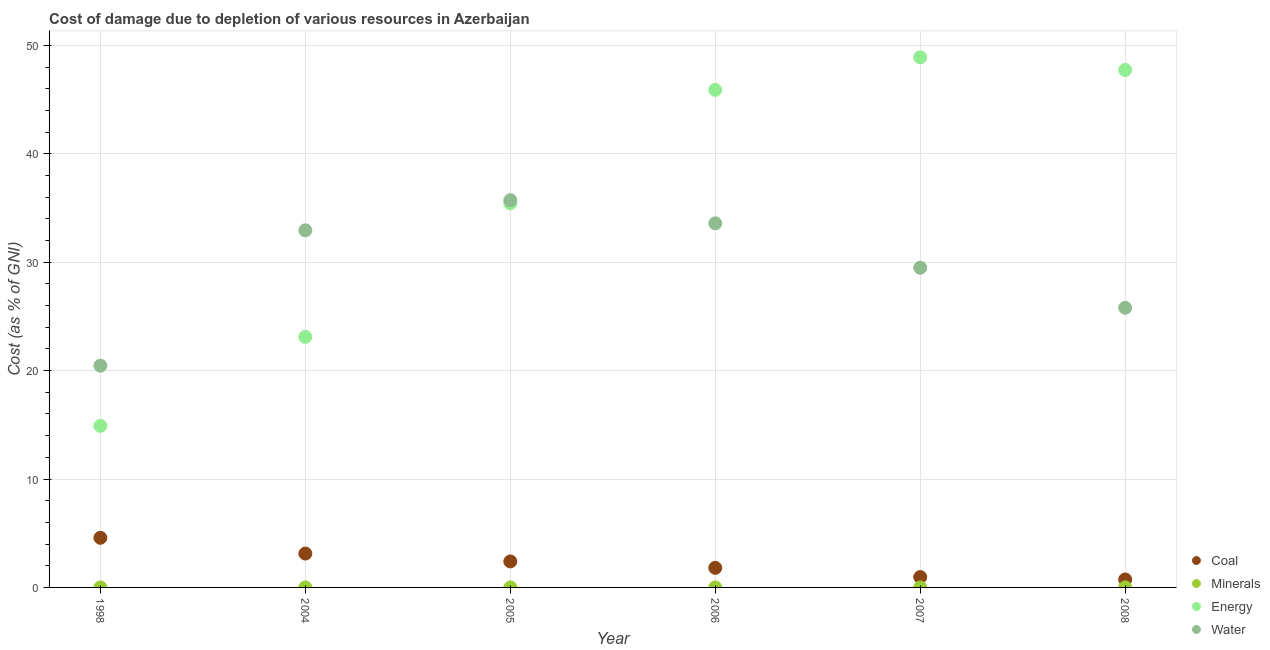What is the cost of damage due to depletion of water in 2005?
Your answer should be compact. 35.72. Across all years, what is the maximum cost of damage due to depletion of energy?
Offer a very short reply. 48.9. Across all years, what is the minimum cost of damage due to depletion of coal?
Provide a succinct answer. 0.74. In which year was the cost of damage due to depletion of minerals maximum?
Your answer should be compact. 2008. What is the total cost of damage due to depletion of minerals in the graph?
Offer a terse response. 0.01. What is the difference between the cost of damage due to depletion of water in 2005 and that in 2006?
Your answer should be very brief. 2.13. What is the difference between the cost of damage due to depletion of coal in 2007 and the cost of damage due to depletion of minerals in 2006?
Keep it short and to the point. 0.95. What is the average cost of damage due to depletion of water per year?
Provide a short and direct response. 29.66. In the year 2007, what is the difference between the cost of damage due to depletion of energy and cost of damage due to depletion of coal?
Your response must be concise. 47.94. In how many years, is the cost of damage due to depletion of energy greater than 16 %?
Provide a short and direct response. 5. What is the ratio of the cost of damage due to depletion of energy in 2004 to that in 2008?
Your answer should be very brief. 0.48. What is the difference between the highest and the second highest cost of damage due to depletion of water?
Provide a short and direct response. 2.13. What is the difference between the highest and the lowest cost of damage due to depletion of water?
Make the answer very short. 15.27. In how many years, is the cost of damage due to depletion of energy greater than the average cost of damage due to depletion of energy taken over all years?
Make the answer very short. 3. Is it the case that in every year, the sum of the cost of damage due to depletion of coal and cost of damage due to depletion of minerals is greater than the cost of damage due to depletion of energy?
Offer a terse response. No. Does the cost of damage due to depletion of energy monotonically increase over the years?
Offer a very short reply. No. Is the cost of damage due to depletion of water strictly greater than the cost of damage due to depletion of minerals over the years?
Offer a very short reply. Yes. How many dotlines are there?
Give a very brief answer. 4. What is the difference between two consecutive major ticks on the Y-axis?
Make the answer very short. 10. Are the values on the major ticks of Y-axis written in scientific E-notation?
Your answer should be compact. No. Does the graph contain any zero values?
Give a very brief answer. No. Does the graph contain grids?
Your answer should be compact. Yes. How many legend labels are there?
Offer a terse response. 4. What is the title of the graph?
Offer a terse response. Cost of damage due to depletion of various resources in Azerbaijan . What is the label or title of the X-axis?
Provide a succinct answer. Year. What is the label or title of the Y-axis?
Provide a succinct answer. Cost (as % of GNI). What is the Cost (as % of GNI) in Coal in 1998?
Your answer should be very brief. 4.58. What is the Cost (as % of GNI) of Minerals in 1998?
Your answer should be very brief. 0. What is the Cost (as % of GNI) in Energy in 1998?
Give a very brief answer. 14.9. What is the Cost (as % of GNI) in Water in 1998?
Your answer should be compact. 20.45. What is the Cost (as % of GNI) in Coal in 2004?
Give a very brief answer. 3.12. What is the Cost (as % of GNI) in Minerals in 2004?
Make the answer very short. 0. What is the Cost (as % of GNI) of Energy in 2004?
Ensure brevity in your answer.  23.11. What is the Cost (as % of GNI) of Water in 2004?
Give a very brief answer. 32.94. What is the Cost (as % of GNI) in Coal in 2005?
Make the answer very short. 2.4. What is the Cost (as % of GNI) in Minerals in 2005?
Your answer should be very brief. 0. What is the Cost (as % of GNI) in Energy in 2005?
Your response must be concise. 35.43. What is the Cost (as % of GNI) in Water in 2005?
Offer a terse response. 35.72. What is the Cost (as % of GNI) of Coal in 2006?
Provide a short and direct response. 1.81. What is the Cost (as % of GNI) of Minerals in 2006?
Offer a terse response. 0. What is the Cost (as % of GNI) of Energy in 2006?
Make the answer very short. 45.89. What is the Cost (as % of GNI) in Water in 2006?
Offer a terse response. 33.59. What is the Cost (as % of GNI) of Coal in 2007?
Your response must be concise. 0.96. What is the Cost (as % of GNI) in Minerals in 2007?
Provide a succinct answer. 0. What is the Cost (as % of GNI) in Energy in 2007?
Your answer should be compact. 48.9. What is the Cost (as % of GNI) of Water in 2007?
Provide a succinct answer. 29.49. What is the Cost (as % of GNI) of Coal in 2008?
Keep it short and to the point. 0.74. What is the Cost (as % of GNI) of Minerals in 2008?
Ensure brevity in your answer.  0. What is the Cost (as % of GNI) in Energy in 2008?
Keep it short and to the point. 47.73. What is the Cost (as % of GNI) of Water in 2008?
Make the answer very short. 25.8. Across all years, what is the maximum Cost (as % of GNI) of Coal?
Make the answer very short. 4.58. Across all years, what is the maximum Cost (as % of GNI) of Minerals?
Offer a very short reply. 0. Across all years, what is the maximum Cost (as % of GNI) in Energy?
Provide a succinct answer. 48.9. Across all years, what is the maximum Cost (as % of GNI) in Water?
Provide a succinct answer. 35.72. Across all years, what is the minimum Cost (as % of GNI) in Coal?
Your response must be concise. 0.74. Across all years, what is the minimum Cost (as % of GNI) in Minerals?
Make the answer very short. 0. Across all years, what is the minimum Cost (as % of GNI) in Energy?
Your answer should be compact. 14.9. Across all years, what is the minimum Cost (as % of GNI) in Water?
Give a very brief answer. 20.45. What is the total Cost (as % of GNI) of Coal in the graph?
Keep it short and to the point. 13.6. What is the total Cost (as % of GNI) of Minerals in the graph?
Your response must be concise. 0.01. What is the total Cost (as % of GNI) in Energy in the graph?
Ensure brevity in your answer.  215.96. What is the total Cost (as % of GNI) of Water in the graph?
Your response must be concise. 177.98. What is the difference between the Cost (as % of GNI) in Coal in 1998 and that in 2004?
Keep it short and to the point. 1.45. What is the difference between the Cost (as % of GNI) of Minerals in 1998 and that in 2004?
Keep it short and to the point. -0. What is the difference between the Cost (as % of GNI) in Energy in 1998 and that in 2004?
Your answer should be very brief. -8.21. What is the difference between the Cost (as % of GNI) of Water in 1998 and that in 2004?
Offer a terse response. -12.49. What is the difference between the Cost (as % of GNI) in Coal in 1998 and that in 2005?
Provide a short and direct response. 2.18. What is the difference between the Cost (as % of GNI) in Minerals in 1998 and that in 2005?
Give a very brief answer. -0. What is the difference between the Cost (as % of GNI) in Energy in 1998 and that in 2005?
Provide a short and direct response. -20.53. What is the difference between the Cost (as % of GNI) in Water in 1998 and that in 2005?
Your response must be concise. -15.27. What is the difference between the Cost (as % of GNI) in Coal in 1998 and that in 2006?
Offer a very short reply. 2.77. What is the difference between the Cost (as % of GNI) in Minerals in 1998 and that in 2006?
Ensure brevity in your answer.  -0. What is the difference between the Cost (as % of GNI) of Energy in 1998 and that in 2006?
Your answer should be very brief. -30.99. What is the difference between the Cost (as % of GNI) of Water in 1998 and that in 2006?
Ensure brevity in your answer.  -13.13. What is the difference between the Cost (as % of GNI) of Coal in 1998 and that in 2007?
Your response must be concise. 3.62. What is the difference between the Cost (as % of GNI) in Minerals in 1998 and that in 2007?
Provide a succinct answer. -0. What is the difference between the Cost (as % of GNI) of Energy in 1998 and that in 2007?
Ensure brevity in your answer.  -34. What is the difference between the Cost (as % of GNI) of Water in 1998 and that in 2007?
Your answer should be very brief. -9.04. What is the difference between the Cost (as % of GNI) in Coal in 1998 and that in 2008?
Keep it short and to the point. 3.84. What is the difference between the Cost (as % of GNI) of Minerals in 1998 and that in 2008?
Give a very brief answer. -0. What is the difference between the Cost (as % of GNI) of Energy in 1998 and that in 2008?
Provide a succinct answer. -32.83. What is the difference between the Cost (as % of GNI) of Water in 1998 and that in 2008?
Make the answer very short. -5.34. What is the difference between the Cost (as % of GNI) in Coal in 2004 and that in 2005?
Give a very brief answer. 0.72. What is the difference between the Cost (as % of GNI) of Minerals in 2004 and that in 2005?
Your answer should be very brief. -0. What is the difference between the Cost (as % of GNI) in Energy in 2004 and that in 2005?
Give a very brief answer. -12.32. What is the difference between the Cost (as % of GNI) in Water in 2004 and that in 2005?
Ensure brevity in your answer.  -2.78. What is the difference between the Cost (as % of GNI) of Coal in 2004 and that in 2006?
Your answer should be compact. 1.32. What is the difference between the Cost (as % of GNI) in Minerals in 2004 and that in 2006?
Provide a short and direct response. -0. What is the difference between the Cost (as % of GNI) of Energy in 2004 and that in 2006?
Offer a terse response. -22.78. What is the difference between the Cost (as % of GNI) in Water in 2004 and that in 2006?
Offer a very short reply. -0.65. What is the difference between the Cost (as % of GNI) in Coal in 2004 and that in 2007?
Your answer should be very brief. 2.17. What is the difference between the Cost (as % of GNI) in Minerals in 2004 and that in 2007?
Offer a very short reply. -0. What is the difference between the Cost (as % of GNI) in Energy in 2004 and that in 2007?
Make the answer very short. -25.79. What is the difference between the Cost (as % of GNI) of Water in 2004 and that in 2007?
Provide a short and direct response. 3.45. What is the difference between the Cost (as % of GNI) of Coal in 2004 and that in 2008?
Your answer should be very brief. 2.39. What is the difference between the Cost (as % of GNI) in Minerals in 2004 and that in 2008?
Make the answer very short. -0. What is the difference between the Cost (as % of GNI) in Energy in 2004 and that in 2008?
Make the answer very short. -24.62. What is the difference between the Cost (as % of GNI) of Water in 2004 and that in 2008?
Your answer should be very brief. 7.15. What is the difference between the Cost (as % of GNI) of Coal in 2005 and that in 2006?
Offer a very short reply. 0.59. What is the difference between the Cost (as % of GNI) of Minerals in 2005 and that in 2006?
Offer a very short reply. -0. What is the difference between the Cost (as % of GNI) in Energy in 2005 and that in 2006?
Ensure brevity in your answer.  -10.46. What is the difference between the Cost (as % of GNI) in Water in 2005 and that in 2006?
Your answer should be very brief. 2.13. What is the difference between the Cost (as % of GNI) of Coal in 2005 and that in 2007?
Offer a terse response. 1.44. What is the difference between the Cost (as % of GNI) in Minerals in 2005 and that in 2007?
Keep it short and to the point. -0. What is the difference between the Cost (as % of GNI) in Energy in 2005 and that in 2007?
Offer a terse response. -13.47. What is the difference between the Cost (as % of GNI) in Water in 2005 and that in 2007?
Keep it short and to the point. 6.23. What is the difference between the Cost (as % of GNI) in Coal in 2005 and that in 2008?
Your response must be concise. 1.66. What is the difference between the Cost (as % of GNI) in Minerals in 2005 and that in 2008?
Give a very brief answer. -0. What is the difference between the Cost (as % of GNI) of Energy in 2005 and that in 2008?
Make the answer very short. -12.3. What is the difference between the Cost (as % of GNI) in Water in 2005 and that in 2008?
Offer a terse response. 9.92. What is the difference between the Cost (as % of GNI) of Coal in 2006 and that in 2007?
Make the answer very short. 0.85. What is the difference between the Cost (as % of GNI) in Minerals in 2006 and that in 2007?
Provide a short and direct response. -0. What is the difference between the Cost (as % of GNI) of Energy in 2006 and that in 2007?
Make the answer very short. -3. What is the difference between the Cost (as % of GNI) in Water in 2006 and that in 2007?
Ensure brevity in your answer.  4.1. What is the difference between the Cost (as % of GNI) in Coal in 2006 and that in 2008?
Your answer should be compact. 1.07. What is the difference between the Cost (as % of GNI) of Minerals in 2006 and that in 2008?
Keep it short and to the point. -0. What is the difference between the Cost (as % of GNI) of Energy in 2006 and that in 2008?
Provide a succinct answer. -1.84. What is the difference between the Cost (as % of GNI) in Water in 2006 and that in 2008?
Provide a short and direct response. 7.79. What is the difference between the Cost (as % of GNI) in Coal in 2007 and that in 2008?
Your answer should be very brief. 0.22. What is the difference between the Cost (as % of GNI) of Minerals in 2007 and that in 2008?
Offer a very short reply. -0. What is the difference between the Cost (as % of GNI) in Energy in 2007 and that in 2008?
Your answer should be compact. 1.17. What is the difference between the Cost (as % of GNI) of Water in 2007 and that in 2008?
Provide a short and direct response. 3.69. What is the difference between the Cost (as % of GNI) in Coal in 1998 and the Cost (as % of GNI) in Minerals in 2004?
Your response must be concise. 4.58. What is the difference between the Cost (as % of GNI) of Coal in 1998 and the Cost (as % of GNI) of Energy in 2004?
Make the answer very short. -18.53. What is the difference between the Cost (as % of GNI) of Coal in 1998 and the Cost (as % of GNI) of Water in 2004?
Provide a short and direct response. -28.36. What is the difference between the Cost (as % of GNI) in Minerals in 1998 and the Cost (as % of GNI) in Energy in 2004?
Give a very brief answer. -23.11. What is the difference between the Cost (as % of GNI) in Minerals in 1998 and the Cost (as % of GNI) in Water in 2004?
Ensure brevity in your answer.  -32.94. What is the difference between the Cost (as % of GNI) in Energy in 1998 and the Cost (as % of GNI) in Water in 2004?
Provide a short and direct response. -18.04. What is the difference between the Cost (as % of GNI) of Coal in 1998 and the Cost (as % of GNI) of Minerals in 2005?
Make the answer very short. 4.58. What is the difference between the Cost (as % of GNI) in Coal in 1998 and the Cost (as % of GNI) in Energy in 2005?
Ensure brevity in your answer.  -30.85. What is the difference between the Cost (as % of GNI) of Coal in 1998 and the Cost (as % of GNI) of Water in 2005?
Make the answer very short. -31.14. What is the difference between the Cost (as % of GNI) of Minerals in 1998 and the Cost (as % of GNI) of Energy in 2005?
Your answer should be compact. -35.43. What is the difference between the Cost (as % of GNI) of Minerals in 1998 and the Cost (as % of GNI) of Water in 2005?
Provide a succinct answer. -35.72. What is the difference between the Cost (as % of GNI) in Energy in 1998 and the Cost (as % of GNI) in Water in 2005?
Your response must be concise. -20.82. What is the difference between the Cost (as % of GNI) in Coal in 1998 and the Cost (as % of GNI) in Minerals in 2006?
Give a very brief answer. 4.58. What is the difference between the Cost (as % of GNI) of Coal in 1998 and the Cost (as % of GNI) of Energy in 2006?
Keep it short and to the point. -41.31. What is the difference between the Cost (as % of GNI) in Coal in 1998 and the Cost (as % of GNI) in Water in 2006?
Your response must be concise. -29.01. What is the difference between the Cost (as % of GNI) in Minerals in 1998 and the Cost (as % of GNI) in Energy in 2006?
Your answer should be very brief. -45.89. What is the difference between the Cost (as % of GNI) of Minerals in 1998 and the Cost (as % of GNI) of Water in 2006?
Keep it short and to the point. -33.59. What is the difference between the Cost (as % of GNI) in Energy in 1998 and the Cost (as % of GNI) in Water in 2006?
Ensure brevity in your answer.  -18.69. What is the difference between the Cost (as % of GNI) in Coal in 1998 and the Cost (as % of GNI) in Minerals in 2007?
Keep it short and to the point. 4.58. What is the difference between the Cost (as % of GNI) of Coal in 1998 and the Cost (as % of GNI) of Energy in 2007?
Offer a terse response. -44.32. What is the difference between the Cost (as % of GNI) in Coal in 1998 and the Cost (as % of GNI) in Water in 2007?
Make the answer very short. -24.91. What is the difference between the Cost (as % of GNI) in Minerals in 1998 and the Cost (as % of GNI) in Energy in 2007?
Make the answer very short. -48.9. What is the difference between the Cost (as % of GNI) of Minerals in 1998 and the Cost (as % of GNI) of Water in 2007?
Ensure brevity in your answer.  -29.49. What is the difference between the Cost (as % of GNI) in Energy in 1998 and the Cost (as % of GNI) in Water in 2007?
Ensure brevity in your answer.  -14.59. What is the difference between the Cost (as % of GNI) in Coal in 1998 and the Cost (as % of GNI) in Minerals in 2008?
Offer a very short reply. 4.57. What is the difference between the Cost (as % of GNI) in Coal in 1998 and the Cost (as % of GNI) in Energy in 2008?
Your response must be concise. -43.15. What is the difference between the Cost (as % of GNI) in Coal in 1998 and the Cost (as % of GNI) in Water in 2008?
Offer a terse response. -21.22. What is the difference between the Cost (as % of GNI) in Minerals in 1998 and the Cost (as % of GNI) in Energy in 2008?
Provide a short and direct response. -47.73. What is the difference between the Cost (as % of GNI) of Minerals in 1998 and the Cost (as % of GNI) of Water in 2008?
Keep it short and to the point. -25.8. What is the difference between the Cost (as % of GNI) in Energy in 1998 and the Cost (as % of GNI) in Water in 2008?
Offer a very short reply. -10.9. What is the difference between the Cost (as % of GNI) of Coal in 2004 and the Cost (as % of GNI) of Minerals in 2005?
Make the answer very short. 3.12. What is the difference between the Cost (as % of GNI) of Coal in 2004 and the Cost (as % of GNI) of Energy in 2005?
Make the answer very short. -32.31. What is the difference between the Cost (as % of GNI) of Coal in 2004 and the Cost (as % of GNI) of Water in 2005?
Make the answer very short. -32.6. What is the difference between the Cost (as % of GNI) of Minerals in 2004 and the Cost (as % of GNI) of Energy in 2005?
Your answer should be compact. -35.43. What is the difference between the Cost (as % of GNI) in Minerals in 2004 and the Cost (as % of GNI) in Water in 2005?
Your response must be concise. -35.72. What is the difference between the Cost (as % of GNI) of Energy in 2004 and the Cost (as % of GNI) of Water in 2005?
Your answer should be compact. -12.61. What is the difference between the Cost (as % of GNI) of Coal in 2004 and the Cost (as % of GNI) of Minerals in 2006?
Offer a terse response. 3.12. What is the difference between the Cost (as % of GNI) of Coal in 2004 and the Cost (as % of GNI) of Energy in 2006?
Give a very brief answer. -42.77. What is the difference between the Cost (as % of GNI) of Coal in 2004 and the Cost (as % of GNI) of Water in 2006?
Ensure brevity in your answer.  -30.46. What is the difference between the Cost (as % of GNI) in Minerals in 2004 and the Cost (as % of GNI) in Energy in 2006?
Offer a very short reply. -45.89. What is the difference between the Cost (as % of GNI) of Minerals in 2004 and the Cost (as % of GNI) of Water in 2006?
Provide a succinct answer. -33.58. What is the difference between the Cost (as % of GNI) in Energy in 2004 and the Cost (as % of GNI) in Water in 2006?
Your response must be concise. -10.48. What is the difference between the Cost (as % of GNI) in Coal in 2004 and the Cost (as % of GNI) in Minerals in 2007?
Ensure brevity in your answer.  3.12. What is the difference between the Cost (as % of GNI) of Coal in 2004 and the Cost (as % of GNI) of Energy in 2007?
Give a very brief answer. -45.77. What is the difference between the Cost (as % of GNI) in Coal in 2004 and the Cost (as % of GNI) in Water in 2007?
Offer a very short reply. -26.37. What is the difference between the Cost (as % of GNI) in Minerals in 2004 and the Cost (as % of GNI) in Energy in 2007?
Your answer should be compact. -48.9. What is the difference between the Cost (as % of GNI) of Minerals in 2004 and the Cost (as % of GNI) of Water in 2007?
Offer a very short reply. -29.49. What is the difference between the Cost (as % of GNI) in Energy in 2004 and the Cost (as % of GNI) in Water in 2007?
Give a very brief answer. -6.38. What is the difference between the Cost (as % of GNI) of Coal in 2004 and the Cost (as % of GNI) of Minerals in 2008?
Your answer should be very brief. 3.12. What is the difference between the Cost (as % of GNI) in Coal in 2004 and the Cost (as % of GNI) in Energy in 2008?
Offer a very short reply. -44.61. What is the difference between the Cost (as % of GNI) of Coal in 2004 and the Cost (as % of GNI) of Water in 2008?
Your answer should be compact. -22.67. What is the difference between the Cost (as % of GNI) in Minerals in 2004 and the Cost (as % of GNI) in Energy in 2008?
Give a very brief answer. -47.73. What is the difference between the Cost (as % of GNI) in Minerals in 2004 and the Cost (as % of GNI) in Water in 2008?
Your response must be concise. -25.79. What is the difference between the Cost (as % of GNI) in Energy in 2004 and the Cost (as % of GNI) in Water in 2008?
Offer a terse response. -2.69. What is the difference between the Cost (as % of GNI) in Coal in 2005 and the Cost (as % of GNI) in Minerals in 2006?
Offer a terse response. 2.4. What is the difference between the Cost (as % of GNI) in Coal in 2005 and the Cost (as % of GNI) in Energy in 2006?
Make the answer very short. -43.49. What is the difference between the Cost (as % of GNI) of Coal in 2005 and the Cost (as % of GNI) of Water in 2006?
Keep it short and to the point. -31.19. What is the difference between the Cost (as % of GNI) of Minerals in 2005 and the Cost (as % of GNI) of Energy in 2006?
Provide a succinct answer. -45.89. What is the difference between the Cost (as % of GNI) of Minerals in 2005 and the Cost (as % of GNI) of Water in 2006?
Provide a short and direct response. -33.58. What is the difference between the Cost (as % of GNI) in Energy in 2005 and the Cost (as % of GNI) in Water in 2006?
Ensure brevity in your answer.  1.84. What is the difference between the Cost (as % of GNI) of Coal in 2005 and the Cost (as % of GNI) of Minerals in 2007?
Provide a succinct answer. 2.4. What is the difference between the Cost (as % of GNI) of Coal in 2005 and the Cost (as % of GNI) of Energy in 2007?
Offer a very short reply. -46.5. What is the difference between the Cost (as % of GNI) in Coal in 2005 and the Cost (as % of GNI) in Water in 2007?
Your answer should be compact. -27.09. What is the difference between the Cost (as % of GNI) in Minerals in 2005 and the Cost (as % of GNI) in Energy in 2007?
Provide a short and direct response. -48.9. What is the difference between the Cost (as % of GNI) in Minerals in 2005 and the Cost (as % of GNI) in Water in 2007?
Provide a short and direct response. -29.49. What is the difference between the Cost (as % of GNI) in Energy in 2005 and the Cost (as % of GNI) in Water in 2007?
Offer a very short reply. 5.94. What is the difference between the Cost (as % of GNI) in Coal in 2005 and the Cost (as % of GNI) in Minerals in 2008?
Your response must be concise. 2.4. What is the difference between the Cost (as % of GNI) of Coal in 2005 and the Cost (as % of GNI) of Energy in 2008?
Make the answer very short. -45.33. What is the difference between the Cost (as % of GNI) in Coal in 2005 and the Cost (as % of GNI) in Water in 2008?
Your answer should be compact. -23.4. What is the difference between the Cost (as % of GNI) in Minerals in 2005 and the Cost (as % of GNI) in Energy in 2008?
Ensure brevity in your answer.  -47.73. What is the difference between the Cost (as % of GNI) of Minerals in 2005 and the Cost (as % of GNI) of Water in 2008?
Your answer should be compact. -25.79. What is the difference between the Cost (as % of GNI) of Energy in 2005 and the Cost (as % of GNI) of Water in 2008?
Your answer should be compact. 9.63. What is the difference between the Cost (as % of GNI) in Coal in 2006 and the Cost (as % of GNI) in Minerals in 2007?
Offer a very short reply. 1.8. What is the difference between the Cost (as % of GNI) in Coal in 2006 and the Cost (as % of GNI) in Energy in 2007?
Your response must be concise. -47.09. What is the difference between the Cost (as % of GNI) in Coal in 2006 and the Cost (as % of GNI) in Water in 2007?
Keep it short and to the point. -27.68. What is the difference between the Cost (as % of GNI) in Minerals in 2006 and the Cost (as % of GNI) in Energy in 2007?
Offer a terse response. -48.9. What is the difference between the Cost (as % of GNI) in Minerals in 2006 and the Cost (as % of GNI) in Water in 2007?
Make the answer very short. -29.49. What is the difference between the Cost (as % of GNI) in Energy in 2006 and the Cost (as % of GNI) in Water in 2007?
Provide a succinct answer. 16.4. What is the difference between the Cost (as % of GNI) in Coal in 2006 and the Cost (as % of GNI) in Minerals in 2008?
Provide a short and direct response. 1.8. What is the difference between the Cost (as % of GNI) in Coal in 2006 and the Cost (as % of GNI) in Energy in 2008?
Keep it short and to the point. -45.92. What is the difference between the Cost (as % of GNI) in Coal in 2006 and the Cost (as % of GNI) in Water in 2008?
Your response must be concise. -23.99. What is the difference between the Cost (as % of GNI) of Minerals in 2006 and the Cost (as % of GNI) of Energy in 2008?
Ensure brevity in your answer.  -47.73. What is the difference between the Cost (as % of GNI) of Minerals in 2006 and the Cost (as % of GNI) of Water in 2008?
Offer a terse response. -25.79. What is the difference between the Cost (as % of GNI) of Energy in 2006 and the Cost (as % of GNI) of Water in 2008?
Offer a very short reply. 20.1. What is the difference between the Cost (as % of GNI) of Coal in 2007 and the Cost (as % of GNI) of Minerals in 2008?
Your answer should be very brief. 0.95. What is the difference between the Cost (as % of GNI) of Coal in 2007 and the Cost (as % of GNI) of Energy in 2008?
Provide a short and direct response. -46.78. What is the difference between the Cost (as % of GNI) in Coal in 2007 and the Cost (as % of GNI) in Water in 2008?
Ensure brevity in your answer.  -24.84. What is the difference between the Cost (as % of GNI) of Minerals in 2007 and the Cost (as % of GNI) of Energy in 2008?
Keep it short and to the point. -47.73. What is the difference between the Cost (as % of GNI) in Minerals in 2007 and the Cost (as % of GNI) in Water in 2008?
Provide a succinct answer. -25.79. What is the difference between the Cost (as % of GNI) in Energy in 2007 and the Cost (as % of GNI) in Water in 2008?
Make the answer very short. 23.1. What is the average Cost (as % of GNI) in Coal per year?
Offer a terse response. 2.27. What is the average Cost (as % of GNI) in Minerals per year?
Provide a succinct answer. 0. What is the average Cost (as % of GNI) in Energy per year?
Offer a terse response. 35.99. What is the average Cost (as % of GNI) of Water per year?
Ensure brevity in your answer.  29.66. In the year 1998, what is the difference between the Cost (as % of GNI) of Coal and Cost (as % of GNI) of Minerals?
Keep it short and to the point. 4.58. In the year 1998, what is the difference between the Cost (as % of GNI) in Coal and Cost (as % of GNI) in Energy?
Make the answer very short. -10.32. In the year 1998, what is the difference between the Cost (as % of GNI) in Coal and Cost (as % of GNI) in Water?
Make the answer very short. -15.87. In the year 1998, what is the difference between the Cost (as % of GNI) of Minerals and Cost (as % of GNI) of Energy?
Keep it short and to the point. -14.9. In the year 1998, what is the difference between the Cost (as % of GNI) in Minerals and Cost (as % of GNI) in Water?
Your answer should be compact. -20.45. In the year 1998, what is the difference between the Cost (as % of GNI) in Energy and Cost (as % of GNI) in Water?
Provide a short and direct response. -5.55. In the year 2004, what is the difference between the Cost (as % of GNI) in Coal and Cost (as % of GNI) in Minerals?
Offer a terse response. 3.12. In the year 2004, what is the difference between the Cost (as % of GNI) in Coal and Cost (as % of GNI) in Energy?
Give a very brief answer. -19.99. In the year 2004, what is the difference between the Cost (as % of GNI) in Coal and Cost (as % of GNI) in Water?
Make the answer very short. -29.82. In the year 2004, what is the difference between the Cost (as % of GNI) of Minerals and Cost (as % of GNI) of Energy?
Provide a short and direct response. -23.11. In the year 2004, what is the difference between the Cost (as % of GNI) of Minerals and Cost (as % of GNI) of Water?
Your answer should be compact. -32.94. In the year 2004, what is the difference between the Cost (as % of GNI) in Energy and Cost (as % of GNI) in Water?
Your answer should be compact. -9.83. In the year 2005, what is the difference between the Cost (as % of GNI) of Coal and Cost (as % of GNI) of Minerals?
Your answer should be very brief. 2.4. In the year 2005, what is the difference between the Cost (as % of GNI) of Coal and Cost (as % of GNI) of Energy?
Give a very brief answer. -33.03. In the year 2005, what is the difference between the Cost (as % of GNI) of Coal and Cost (as % of GNI) of Water?
Offer a terse response. -33.32. In the year 2005, what is the difference between the Cost (as % of GNI) in Minerals and Cost (as % of GNI) in Energy?
Provide a short and direct response. -35.43. In the year 2005, what is the difference between the Cost (as % of GNI) of Minerals and Cost (as % of GNI) of Water?
Provide a succinct answer. -35.72. In the year 2005, what is the difference between the Cost (as % of GNI) of Energy and Cost (as % of GNI) of Water?
Offer a terse response. -0.29. In the year 2006, what is the difference between the Cost (as % of GNI) in Coal and Cost (as % of GNI) in Minerals?
Your response must be concise. 1.81. In the year 2006, what is the difference between the Cost (as % of GNI) of Coal and Cost (as % of GNI) of Energy?
Your response must be concise. -44.09. In the year 2006, what is the difference between the Cost (as % of GNI) in Coal and Cost (as % of GNI) in Water?
Keep it short and to the point. -31.78. In the year 2006, what is the difference between the Cost (as % of GNI) of Minerals and Cost (as % of GNI) of Energy?
Offer a terse response. -45.89. In the year 2006, what is the difference between the Cost (as % of GNI) of Minerals and Cost (as % of GNI) of Water?
Your answer should be compact. -33.58. In the year 2006, what is the difference between the Cost (as % of GNI) of Energy and Cost (as % of GNI) of Water?
Provide a short and direct response. 12.31. In the year 2007, what is the difference between the Cost (as % of GNI) of Coal and Cost (as % of GNI) of Minerals?
Your answer should be very brief. 0.95. In the year 2007, what is the difference between the Cost (as % of GNI) in Coal and Cost (as % of GNI) in Energy?
Your answer should be very brief. -47.94. In the year 2007, what is the difference between the Cost (as % of GNI) in Coal and Cost (as % of GNI) in Water?
Provide a short and direct response. -28.53. In the year 2007, what is the difference between the Cost (as % of GNI) of Minerals and Cost (as % of GNI) of Energy?
Offer a very short reply. -48.89. In the year 2007, what is the difference between the Cost (as % of GNI) in Minerals and Cost (as % of GNI) in Water?
Provide a succinct answer. -29.49. In the year 2007, what is the difference between the Cost (as % of GNI) in Energy and Cost (as % of GNI) in Water?
Offer a very short reply. 19.41. In the year 2008, what is the difference between the Cost (as % of GNI) of Coal and Cost (as % of GNI) of Minerals?
Your response must be concise. 0.73. In the year 2008, what is the difference between the Cost (as % of GNI) of Coal and Cost (as % of GNI) of Energy?
Offer a terse response. -47. In the year 2008, what is the difference between the Cost (as % of GNI) in Coal and Cost (as % of GNI) in Water?
Give a very brief answer. -25.06. In the year 2008, what is the difference between the Cost (as % of GNI) in Minerals and Cost (as % of GNI) in Energy?
Provide a succinct answer. -47.73. In the year 2008, what is the difference between the Cost (as % of GNI) of Minerals and Cost (as % of GNI) of Water?
Your answer should be very brief. -25.79. In the year 2008, what is the difference between the Cost (as % of GNI) of Energy and Cost (as % of GNI) of Water?
Keep it short and to the point. 21.94. What is the ratio of the Cost (as % of GNI) in Coal in 1998 to that in 2004?
Offer a very short reply. 1.47. What is the ratio of the Cost (as % of GNI) in Minerals in 1998 to that in 2004?
Provide a short and direct response. 0.2. What is the ratio of the Cost (as % of GNI) of Energy in 1998 to that in 2004?
Keep it short and to the point. 0.64. What is the ratio of the Cost (as % of GNI) of Water in 1998 to that in 2004?
Offer a terse response. 0.62. What is the ratio of the Cost (as % of GNI) in Coal in 1998 to that in 2005?
Offer a very short reply. 1.91. What is the ratio of the Cost (as % of GNI) of Minerals in 1998 to that in 2005?
Your response must be concise. 0.18. What is the ratio of the Cost (as % of GNI) in Energy in 1998 to that in 2005?
Your response must be concise. 0.42. What is the ratio of the Cost (as % of GNI) of Water in 1998 to that in 2005?
Provide a short and direct response. 0.57. What is the ratio of the Cost (as % of GNI) of Coal in 1998 to that in 2006?
Offer a very short reply. 2.53. What is the ratio of the Cost (as % of GNI) of Minerals in 1998 to that in 2006?
Your response must be concise. 0.17. What is the ratio of the Cost (as % of GNI) in Energy in 1998 to that in 2006?
Your response must be concise. 0.32. What is the ratio of the Cost (as % of GNI) of Water in 1998 to that in 2006?
Offer a terse response. 0.61. What is the ratio of the Cost (as % of GNI) of Coal in 1998 to that in 2007?
Provide a succinct answer. 4.79. What is the ratio of the Cost (as % of GNI) in Minerals in 1998 to that in 2007?
Keep it short and to the point. 0.07. What is the ratio of the Cost (as % of GNI) of Energy in 1998 to that in 2007?
Your answer should be compact. 0.3. What is the ratio of the Cost (as % of GNI) in Water in 1998 to that in 2007?
Provide a short and direct response. 0.69. What is the ratio of the Cost (as % of GNI) in Coal in 1998 to that in 2008?
Ensure brevity in your answer.  6.23. What is the ratio of the Cost (as % of GNI) in Minerals in 1998 to that in 2008?
Offer a terse response. 0.05. What is the ratio of the Cost (as % of GNI) of Energy in 1998 to that in 2008?
Your response must be concise. 0.31. What is the ratio of the Cost (as % of GNI) of Water in 1998 to that in 2008?
Keep it short and to the point. 0.79. What is the ratio of the Cost (as % of GNI) in Coal in 2004 to that in 2005?
Offer a very short reply. 1.3. What is the ratio of the Cost (as % of GNI) in Minerals in 2004 to that in 2005?
Your response must be concise. 0.94. What is the ratio of the Cost (as % of GNI) in Energy in 2004 to that in 2005?
Your answer should be compact. 0.65. What is the ratio of the Cost (as % of GNI) in Water in 2004 to that in 2005?
Provide a succinct answer. 0.92. What is the ratio of the Cost (as % of GNI) in Coal in 2004 to that in 2006?
Your answer should be very brief. 1.73. What is the ratio of the Cost (as % of GNI) in Minerals in 2004 to that in 2006?
Your answer should be very brief. 0.87. What is the ratio of the Cost (as % of GNI) of Energy in 2004 to that in 2006?
Your answer should be very brief. 0.5. What is the ratio of the Cost (as % of GNI) of Water in 2004 to that in 2006?
Your response must be concise. 0.98. What is the ratio of the Cost (as % of GNI) in Coal in 2004 to that in 2007?
Ensure brevity in your answer.  3.27. What is the ratio of the Cost (as % of GNI) in Minerals in 2004 to that in 2007?
Provide a succinct answer. 0.36. What is the ratio of the Cost (as % of GNI) of Energy in 2004 to that in 2007?
Provide a short and direct response. 0.47. What is the ratio of the Cost (as % of GNI) in Water in 2004 to that in 2007?
Give a very brief answer. 1.12. What is the ratio of the Cost (as % of GNI) in Coal in 2004 to that in 2008?
Offer a very short reply. 4.25. What is the ratio of the Cost (as % of GNI) of Minerals in 2004 to that in 2008?
Offer a very short reply. 0.26. What is the ratio of the Cost (as % of GNI) of Energy in 2004 to that in 2008?
Make the answer very short. 0.48. What is the ratio of the Cost (as % of GNI) in Water in 2004 to that in 2008?
Your response must be concise. 1.28. What is the ratio of the Cost (as % of GNI) of Coal in 2005 to that in 2006?
Provide a short and direct response. 1.33. What is the ratio of the Cost (as % of GNI) in Minerals in 2005 to that in 2006?
Your answer should be very brief. 0.92. What is the ratio of the Cost (as % of GNI) in Energy in 2005 to that in 2006?
Make the answer very short. 0.77. What is the ratio of the Cost (as % of GNI) in Water in 2005 to that in 2006?
Make the answer very short. 1.06. What is the ratio of the Cost (as % of GNI) of Coal in 2005 to that in 2007?
Provide a succinct answer. 2.51. What is the ratio of the Cost (as % of GNI) in Minerals in 2005 to that in 2007?
Your answer should be compact. 0.39. What is the ratio of the Cost (as % of GNI) of Energy in 2005 to that in 2007?
Give a very brief answer. 0.72. What is the ratio of the Cost (as % of GNI) of Water in 2005 to that in 2007?
Provide a short and direct response. 1.21. What is the ratio of the Cost (as % of GNI) of Coal in 2005 to that in 2008?
Keep it short and to the point. 3.26. What is the ratio of the Cost (as % of GNI) of Minerals in 2005 to that in 2008?
Provide a succinct answer. 0.28. What is the ratio of the Cost (as % of GNI) in Energy in 2005 to that in 2008?
Ensure brevity in your answer.  0.74. What is the ratio of the Cost (as % of GNI) of Water in 2005 to that in 2008?
Provide a succinct answer. 1.38. What is the ratio of the Cost (as % of GNI) of Coal in 2006 to that in 2007?
Your answer should be compact. 1.89. What is the ratio of the Cost (as % of GNI) in Minerals in 2006 to that in 2007?
Provide a short and direct response. 0.42. What is the ratio of the Cost (as % of GNI) in Energy in 2006 to that in 2007?
Make the answer very short. 0.94. What is the ratio of the Cost (as % of GNI) of Water in 2006 to that in 2007?
Ensure brevity in your answer.  1.14. What is the ratio of the Cost (as % of GNI) of Coal in 2006 to that in 2008?
Ensure brevity in your answer.  2.46. What is the ratio of the Cost (as % of GNI) of Minerals in 2006 to that in 2008?
Make the answer very short. 0.3. What is the ratio of the Cost (as % of GNI) of Energy in 2006 to that in 2008?
Your answer should be compact. 0.96. What is the ratio of the Cost (as % of GNI) of Water in 2006 to that in 2008?
Keep it short and to the point. 1.3. What is the ratio of the Cost (as % of GNI) in Coal in 2007 to that in 2008?
Your answer should be very brief. 1.3. What is the ratio of the Cost (as % of GNI) in Minerals in 2007 to that in 2008?
Your answer should be compact. 0.73. What is the ratio of the Cost (as % of GNI) of Energy in 2007 to that in 2008?
Your response must be concise. 1.02. What is the ratio of the Cost (as % of GNI) of Water in 2007 to that in 2008?
Offer a terse response. 1.14. What is the difference between the highest and the second highest Cost (as % of GNI) of Coal?
Give a very brief answer. 1.45. What is the difference between the highest and the second highest Cost (as % of GNI) of Minerals?
Ensure brevity in your answer.  0. What is the difference between the highest and the second highest Cost (as % of GNI) in Energy?
Keep it short and to the point. 1.17. What is the difference between the highest and the second highest Cost (as % of GNI) of Water?
Keep it short and to the point. 2.13. What is the difference between the highest and the lowest Cost (as % of GNI) of Coal?
Your answer should be compact. 3.84. What is the difference between the highest and the lowest Cost (as % of GNI) of Minerals?
Keep it short and to the point. 0. What is the difference between the highest and the lowest Cost (as % of GNI) of Energy?
Your response must be concise. 34. What is the difference between the highest and the lowest Cost (as % of GNI) in Water?
Provide a short and direct response. 15.27. 